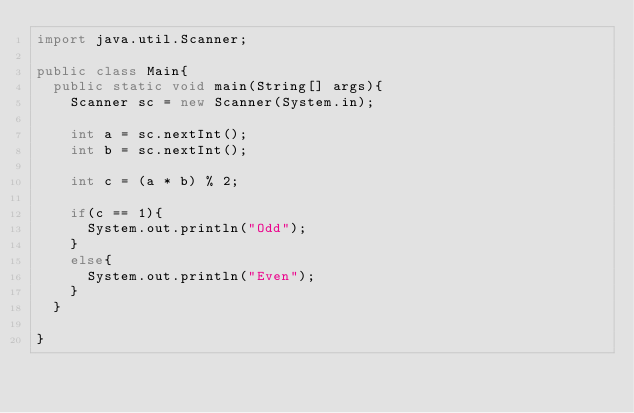<code> <loc_0><loc_0><loc_500><loc_500><_Java_>import java.util.Scanner;

public class Main{
	public static void main(String[] args){
		Scanner sc = new Scanner(System.in);

		int a = sc.nextInt();
		int b = sc.nextInt();

		int c = (a * b) % 2;

		if(c == 1){
			System.out.println("Odd");
		}
		else{
			System.out.println("Even");
		}
	}

}</code> 